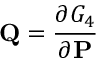Convert formula to latex. <formula><loc_0><loc_0><loc_500><loc_500>Q = { \frac { \partial G _ { 4 } } { \partial P } }</formula> 